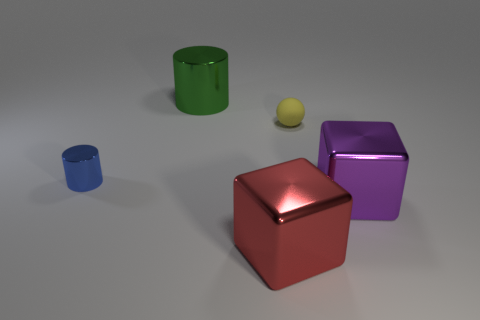There is a big thing on the right side of the big red shiny object that is on the right side of the big green metal cylinder; are there any blue things that are on the right side of it? Upon closer inspection, there actually appears to be a small blue cylindrical object to the left side of the red cube, not on the right as initially queried. So, in direct answer to the question, there are no blue things on the right side of the big red object. To the right, there is a purple cube and a yellow sphere instead. 